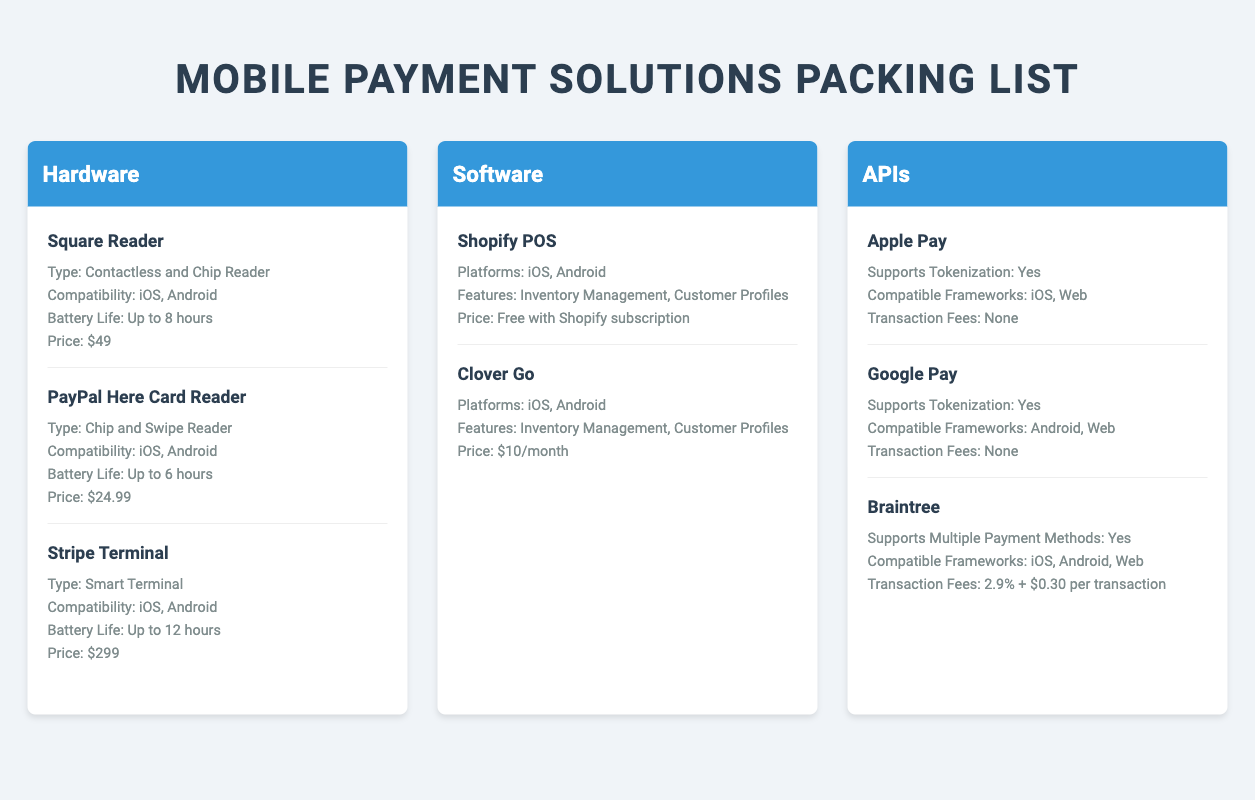What type of reader is the Square Reader? The Square Reader is classified as a Contactless and Chip Reader according to the document.
Answer: Contactless and Chip Reader What is the battery life of the Stripe Terminal? The document specifies that the Stripe Terminal has a battery life of up to 12 hours.
Answer: Up to 12 hours How much does Clover Go cost per month? The document mentions that Clover Go costs $10 per month.
Answer: $10/month Which mobile payment tool supports tokenization and is compatible with iOS? The document states that Apple Pay supports tokenization and is compatible with iOS.
Answer: Apple Pay What are the compatible frameworks for Google Pay? The document indicates that Google Pay is compatible with Android and Web frameworks.
Answer: Android, Web Which hardware has the lowest price among those listed? The document lists the PayPal Here Card Reader as having the lowest price at $24.99.
Answer: $24.99 What features does Shopify POS offer? The document specifies that Shopify POS offers Inventory Management and Customer Profiles.
Answer: Inventory Management, Customer Profiles How many mobile payment tools are listed under the APIs category? The document counts three tools listed under the APIs category: Apple Pay, Google Pay, and Braintree.
Answer: Three What type of payment method does Braintree support? According to the document, Braintree supports multiple payment methods.
Answer: Multiple Payment Methods 